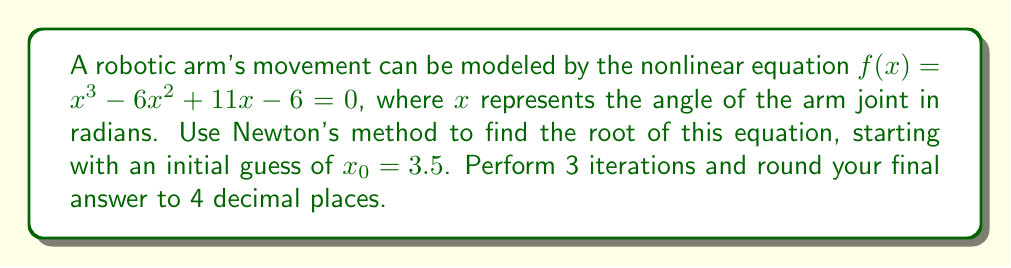Provide a solution to this math problem. Newton's method is given by the formula:

$$x_{n+1} = x_n - \frac{f(x_n)}{f'(x_n)}$$

where $f'(x)$ is the derivative of $f(x)$.

Step 1: Calculate $f'(x)$
$f'(x) = 3x^2 - 12x + 11$

Step 2: Implement Newton's method

Iteration 1:
$f(3.5) = 3.5^3 - 6(3.5)^2 + 11(3.5) - 6 = 2.375$
$f'(3.5) = 3(3.5)^2 - 12(3.5) + 11 = 2.75$

$x_1 = 3.5 - \frac{2.375}{2.75} = 2.6364$

Iteration 2:
$f(2.6364) = 2.6364^3 - 6(2.6364)^2 + 11(2.6364) - 6 = 0.1893$
$f'(2.6364) = 3(2.6364)^2 - 12(2.6364) + 11 = 2.5456$

$x_2 = 2.6364 - \frac{0.1893}{2.5456} = 2.5620$

Iteration 3:
$f(2.5620) = 2.5620^3 - 6(2.5620)^2 + 11(2.5620) - 6 = 0.0012$
$f'(2.5620) = 3(2.5620)^2 - 12(2.5620) + 11 = 2.4860$

$x_3 = 2.5620 - \frac{0.0012}{2.4860} = 2.5615$

Rounding to 4 decimal places: 2.5615
Answer: 2.5615 